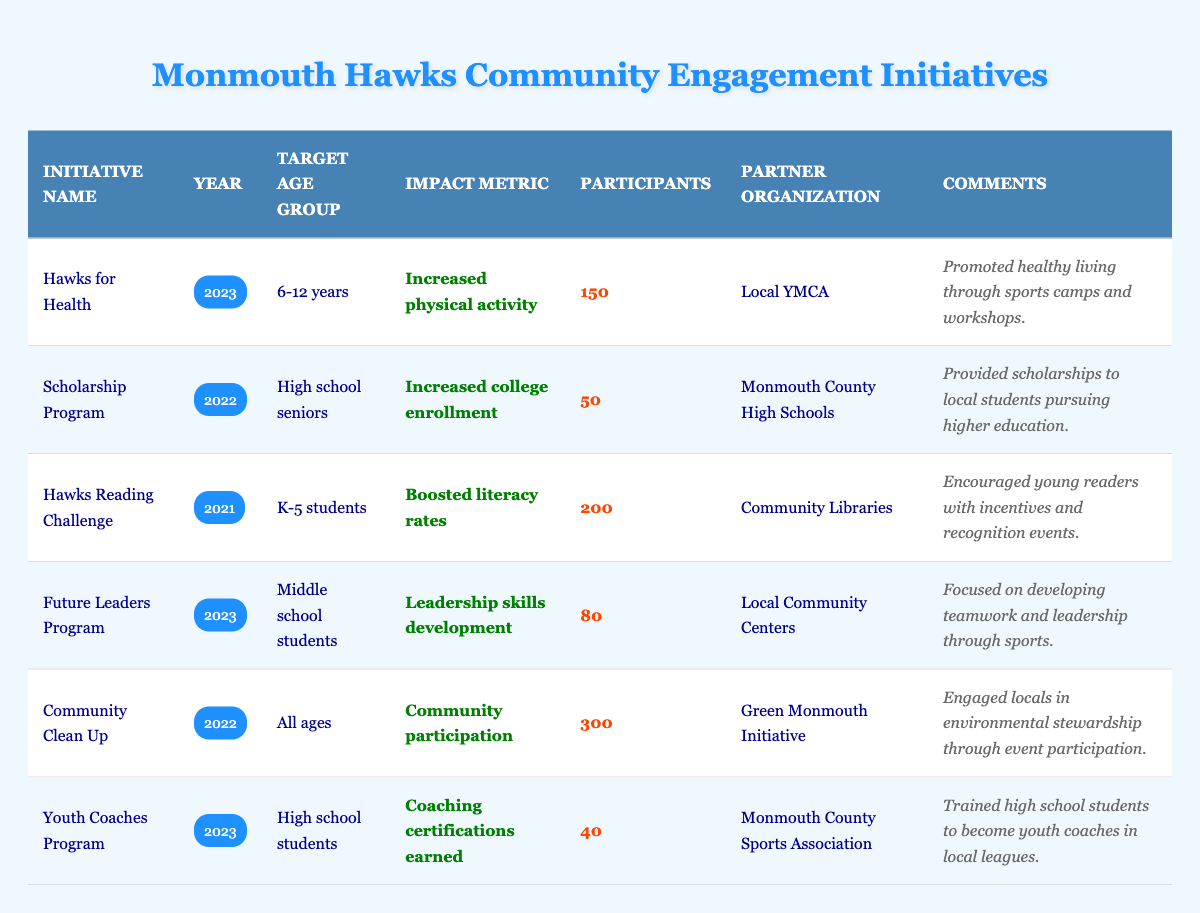What was the impact metric for the "Hawks for Health" initiative? The "Hawks for Health" initiative, which took place in 2023, had the impact metric of "Increased physical activity" as indicated in the table.
Answer: Increased physical activity How many participants were involved in the "Community Clean Up" initiative? The "Community Clean Up" initiative had a total of 300 participants, which is explicitly mentioned in the table.
Answer: 300 Which initiative had the highest number of participants? By comparing the number of participants for each initiative, the "Community Clean Up" with 300 participants has the highest value.
Answer: Community Clean Up Was there an initiative targeting high school students? The table shows two initiatives that target high school students: the "Scholarship Program" and the "Youth Coaches Program." Therefore, the answer is yes.
Answer: Yes What was the average number of participants across all initiatives in 2023? The initiatives in 2023 are "Hawks for Health" (150 participants), "Future Leaders Program" (80 participants), and "Youth Coaches Program" (40 participants). The total number of participants is 150 + 80 + 40 = 270. Dividing by 3 (the number of initiatives) gives an average of 270/3 = 90.
Answer: 90 How many initiatives were focused on youth between the ages of 13 and 18? The table indicates that only one initiative, the "Youth Coaches Program" for high school students, is explicitly tailored for that age group, leading to the conclusion that there is just one initiative.
Answer: 1 Which partner organization collaborated with the "Hawks Reading Challenge"? The "Hawks Reading Challenge" partnered with "Community Libraries," as stated in the table.
Answer: Community Libraries What was the primary goal of the "Future Leaders Program"? The "Future Leaders Program" aimed to develop leadership skills, as explicitly mentioned in the table.
Answer: Leadership skills development What percentage of participants in 2022 initiatives were involved in the "Community Clean Up"? The initiatives in 2022 include "Scholarship Program" with 50 participants and "Community Clean Up" with 300 participants. The total for 2022 is 50 + 300 = 350. The percentage for "Community Clean Up" is (300/350) * 100 = 85.71%.
Answer: 85.71% 